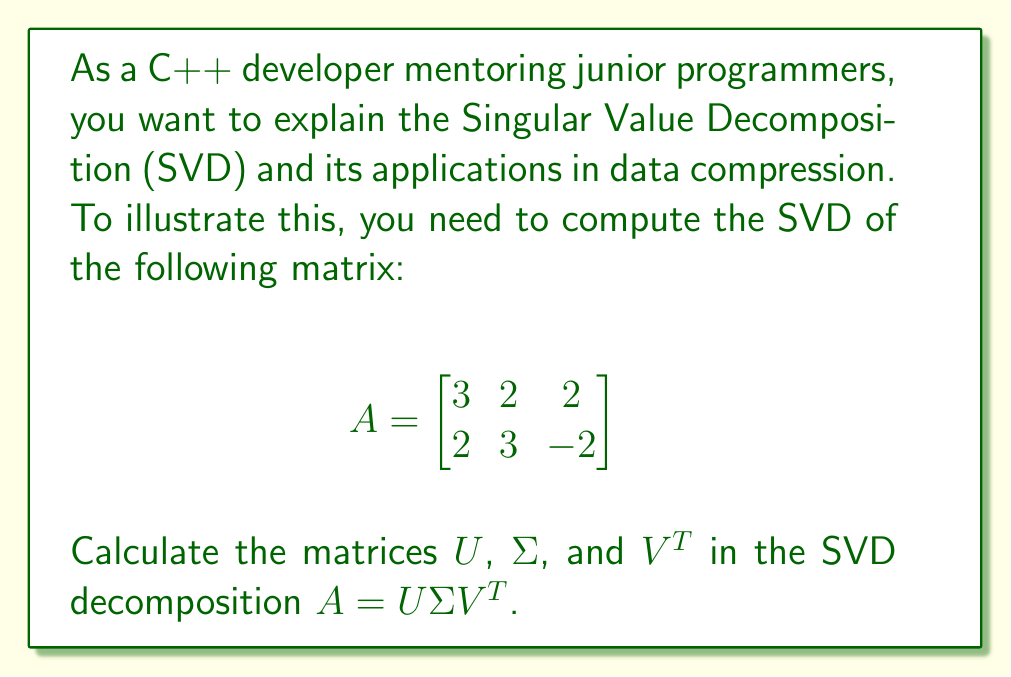Solve this math problem. To compute the SVD of matrix $A$, we follow these steps:

1. Calculate $A^TA$ and $AA^T$:
   $$A^TA = \begin{bmatrix}
   3 & 2 & 2 \\
   2 & 3 & -2 \\
   2 & -2 & 3
   \end{bmatrix}$$
   
   $$AA^T = \begin{bmatrix}
   17 & 10 \\
   10 & 17
   \end{bmatrix}$$

2. Find eigenvalues of $A^TA$:
   $\det(A^TA - \lambda I) = 0$
   $\lambda_1 = 9, \lambda_2 = 5, \lambda_3 = 1$

3. Singular values are square roots of these eigenvalues:
   $\sigma_1 = 3, \sigma_2 = \sqrt{5}, \sigma_3 = 1$

4. Construct $\Sigma$:
   $$\Sigma = \begin{bmatrix}
   3 & 0 & 0 \\
   0 & \sqrt{5} & 0
   \end{bmatrix}$$

5. Find eigenvectors of $A^TA$ for $V$:
   For $\lambda_1 = 9$: $v_1 = \frac{1}{\sqrt{3}}[1, 1, 1]^T$
   For $\lambda_2 = 5$: $v_2 = \frac{1}{\sqrt{6}}[-1, 2, -1]^T$
   For $\lambda_3 = 1$: $v_3 = \frac{1}{\sqrt{2}}[-1, 0, 1]^T$

6. Construct $V$:
   $$V = \begin{bmatrix}
   \frac{1}{\sqrt{3}} & -\frac{1}{\sqrt{6}} & -\frac{1}{\sqrt{2}} \\
   \frac{1}{\sqrt{3}} & \frac{2}{\sqrt{6}} & 0 \\
   \frac{1}{\sqrt{3}} & -\frac{1}{\sqrt{6}} & \frac{1}{\sqrt{2}}
   \end{bmatrix}$$

7. Calculate $U$ columns:
   $u_1 = \frac{1}{\sigma_1}Av_1 = \frac{1}{\sqrt{17}}[3, 2]^T$
   $u_2 = \frac{1}{\sigma_2}Av_2 = \frac{1}{\sqrt{17}}[-2, 3]^T$

8. Construct $U$:
   $$U = \begin{bmatrix}
   \frac{3}{\sqrt{17}} & -\frac{2}{\sqrt{17}} \\
   \frac{2}{\sqrt{17}} & \frac{3}{\sqrt{17}}
   \end{bmatrix}$$

Thus, we have computed the SVD decomposition $A = U\Sigma V^T$.
Answer: $U = \begin{bmatrix}
\frac{3}{\sqrt{17}} & -\frac{2}{\sqrt{17}} \\
\frac{2}{\sqrt{17}} & \frac{3}{\sqrt{17}}
\end{bmatrix}$,
$\Sigma = \begin{bmatrix}
3 & 0 & 0 \\
0 & \sqrt{5} & 0
\end{bmatrix}$,
$V^T = \begin{bmatrix}
\frac{1}{\sqrt{3}} & \frac{1}{\sqrt{3}} & \frac{1}{\sqrt{3}} \\
-\frac{1}{\sqrt{6}} & \frac{2}{\sqrt{6}} & -\frac{1}{\sqrt{6}} \\
-\frac{1}{\sqrt{2}} & 0 & \frac{1}{\sqrt{2}}
\end{bmatrix}$ 